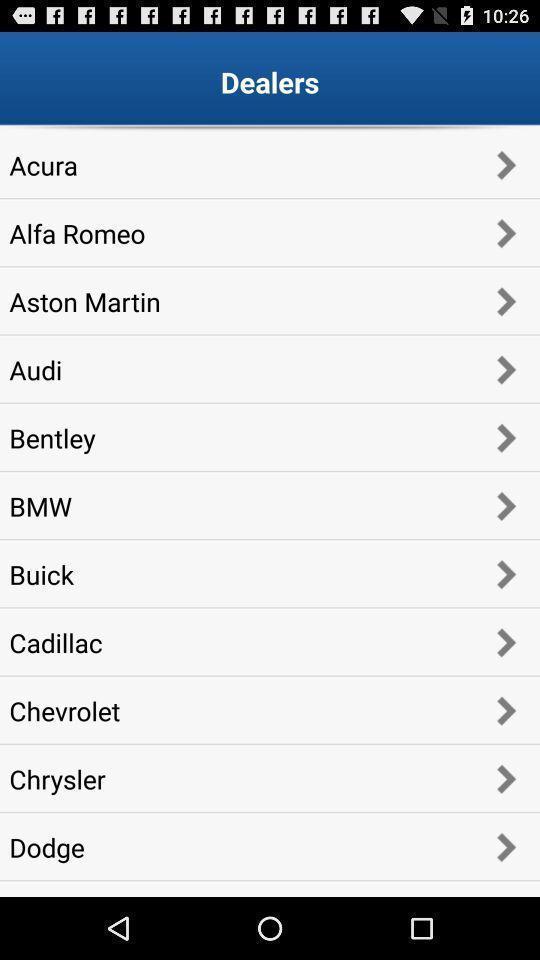Give me a narrative description of this picture. Screen displaying list of dealers. 